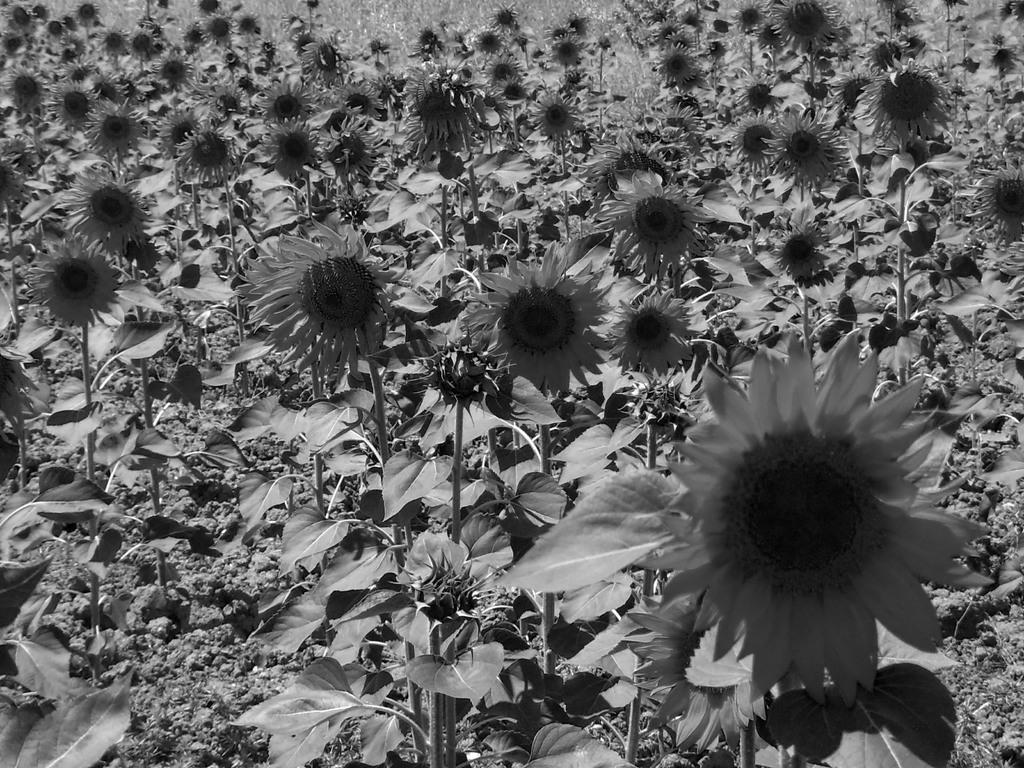What type of plants can be seen in the image? There are flowers and leaves in the image. What is the color scheme of the image? The image is in black and white. Can you see a goldfish swimming in the image? There is no goldfish present in the image. What type of wood can be seen in the image? There is no wood present in the image. 